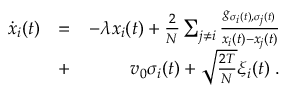Convert formula to latex. <formula><loc_0><loc_0><loc_500><loc_500>\begin{array} { r l r } { \dot { x } _ { i } ( t ) } & { = } & { - \lambda x _ { i } ( t ) + \frac { 2 } { N } \sum _ { j \neq i } \frac { g _ { \sigma _ { i } ( t ) , \sigma _ { j } ( t ) } } { x _ { i } ( t ) - x _ { j } ( t ) } } \\ & { + } & { v _ { 0 } \sigma _ { i } ( t ) + \sqrt { \frac { 2 T } { N } } \xi _ { i } ( t ) \, . } \end{array}</formula> 